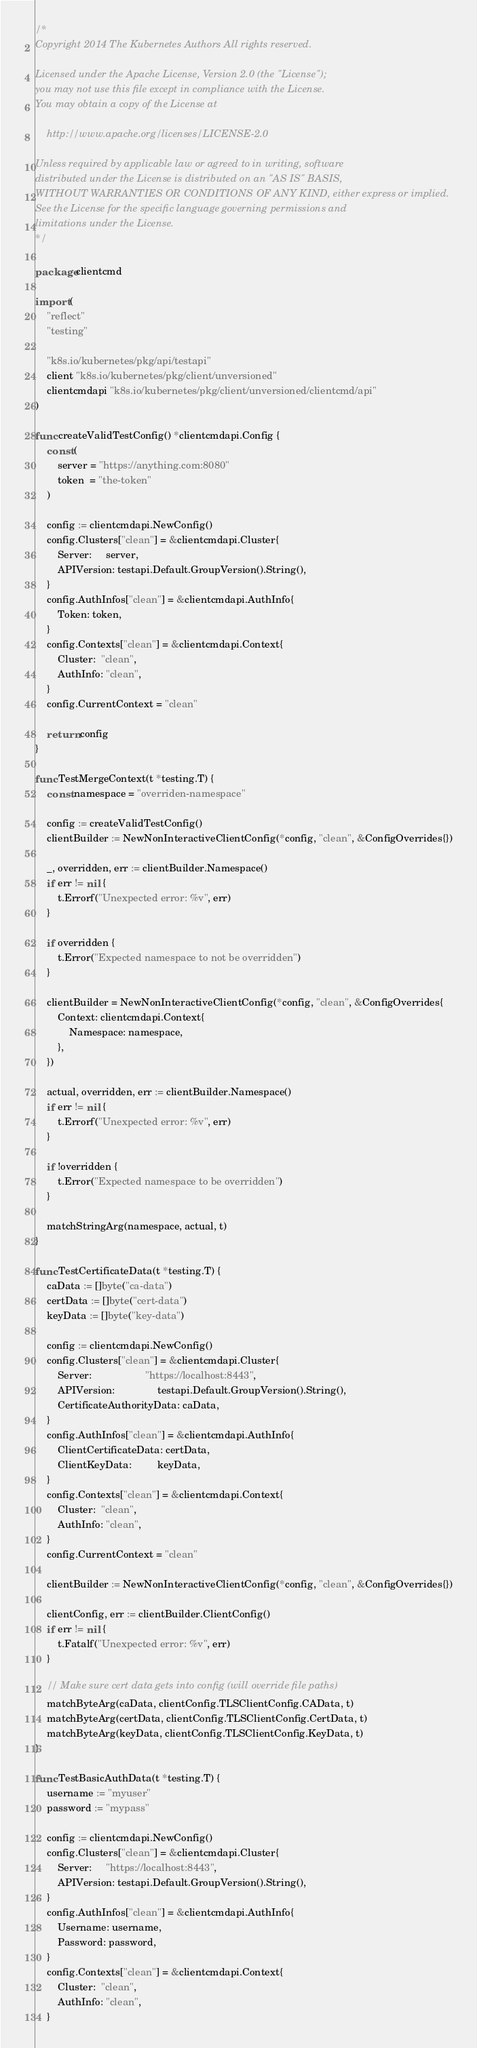<code> <loc_0><loc_0><loc_500><loc_500><_Go_>/*
Copyright 2014 The Kubernetes Authors All rights reserved.

Licensed under the Apache License, Version 2.0 (the "License");
you may not use this file except in compliance with the License.
You may obtain a copy of the License at

    http://www.apache.org/licenses/LICENSE-2.0

Unless required by applicable law or agreed to in writing, software
distributed under the License is distributed on an "AS IS" BASIS,
WITHOUT WARRANTIES OR CONDITIONS OF ANY KIND, either express or implied.
See the License for the specific language governing permissions and
limitations under the License.
*/

package clientcmd

import (
	"reflect"
	"testing"

	"k8s.io/kubernetes/pkg/api/testapi"
	client "k8s.io/kubernetes/pkg/client/unversioned"
	clientcmdapi "k8s.io/kubernetes/pkg/client/unversioned/clientcmd/api"
)

func createValidTestConfig() *clientcmdapi.Config {
	const (
		server = "https://anything.com:8080"
		token  = "the-token"
	)

	config := clientcmdapi.NewConfig()
	config.Clusters["clean"] = &clientcmdapi.Cluster{
		Server:     server,
		APIVersion: testapi.Default.GroupVersion().String(),
	}
	config.AuthInfos["clean"] = &clientcmdapi.AuthInfo{
		Token: token,
	}
	config.Contexts["clean"] = &clientcmdapi.Context{
		Cluster:  "clean",
		AuthInfo: "clean",
	}
	config.CurrentContext = "clean"

	return config
}

func TestMergeContext(t *testing.T) {
	const namespace = "overriden-namespace"

	config := createValidTestConfig()
	clientBuilder := NewNonInteractiveClientConfig(*config, "clean", &ConfigOverrides{})

	_, overridden, err := clientBuilder.Namespace()
	if err != nil {
		t.Errorf("Unexpected error: %v", err)
	}

	if overridden {
		t.Error("Expected namespace to not be overridden")
	}

	clientBuilder = NewNonInteractiveClientConfig(*config, "clean", &ConfigOverrides{
		Context: clientcmdapi.Context{
			Namespace: namespace,
		},
	})

	actual, overridden, err := clientBuilder.Namespace()
	if err != nil {
		t.Errorf("Unexpected error: %v", err)
	}

	if !overridden {
		t.Error("Expected namespace to be overridden")
	}

	matchStringArg(namespace, actual, t)
}

func TestCertificateData(t *testing.T) {
	caData := []byte("ca-data")
	certData := []byte("cert-data")
	keyData := []byte("key-data")

	config := clientcmdapi.NewConfig()
	config.Clusters["clean"] = &clientcmdapi.Cluster{
		Server:                   "https://localhost:8443",
		APIVersion:               testapi.Default.GroupVersion().String(),
		CertificateAuthorityData: caData,
	}
	config.AuthInfos["clean"] = &clientcmdapi.AuthInfo{
		ClientCertificateData: certData,
		ClientKeyData:         keyData,
	}
	config.Contexts["clean"] = &clientcmdapi.Context{
		Cluster:  "clean",
		AuthInfo: "clean",
	}
	config.CurrentContext = "clean"

	clientBuilder := NewNonInteractiveClientConfig(*config, "clean", &ConfigOverrides{})

	clientConfig, err := clientBuilder.ClientConfig()
	if err != nil {
		t.Fatalf("Unexpected error: %v", err)
	}

	// Make sure cert data gets into config (will override file paths)
	matchByteArg(caData, clientConfig.TLSClientConfig.CAData, t)
	matchByteArg(certData, clientConfig.TLSClientConfig.CertData, t)
	matchByteArg(keyData, clientConfig.TLSClientConfig.KeyData, t)
}

func TestBasicAuthData(t *testing.T) {
	username := "myuser"
	password := "mypass"

	config := clientcmdapi.NewConfig()
	config.Clusters["clean"] = &clientcmdapi.Cluster{
		Server:     "https://localhost:8443",
		APIVersion: testapi.Default.GroupVersion().String(),
	}
	config.AuthInfos["clean"] = &clientcmdapi.AuthInfo{
		Username: username,
		Password: password,
	}
	config.Contexts["clean"] = &clientcmdapi.Context{
		Cluster:  "clean",
		AuthInfo: "clean",
	}</code> 